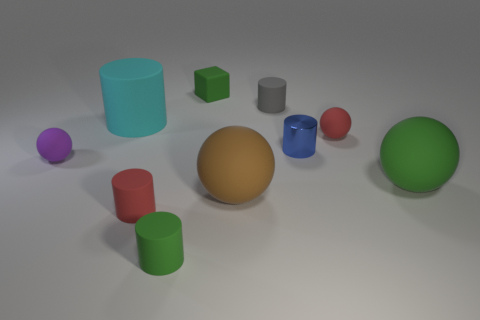Subtract all green matte cylinders. How many cylinders are left? 4 Subtract all green cylinders. How many cylinders are left? 4 Subtract all cubes. How many objects are left? 9 Add 5 green matte cylinders. How many green matte cylinders are left? 6 Add 6 small red cylinders. How many small red cylinders exist? 7 Subtract 0 blue blocks. How many objects are left? 10 Subtract 5 cylinders. How many cylinders are left? 0 Subtract all purple cubes. Subtract all blue balls. How many cubes are left? 1 Subtract all purple cubes. How many brown spheres are left? 1 Subtract all large gray objects. Subtract all cyan matte cylinders. How many objects are left? 9 